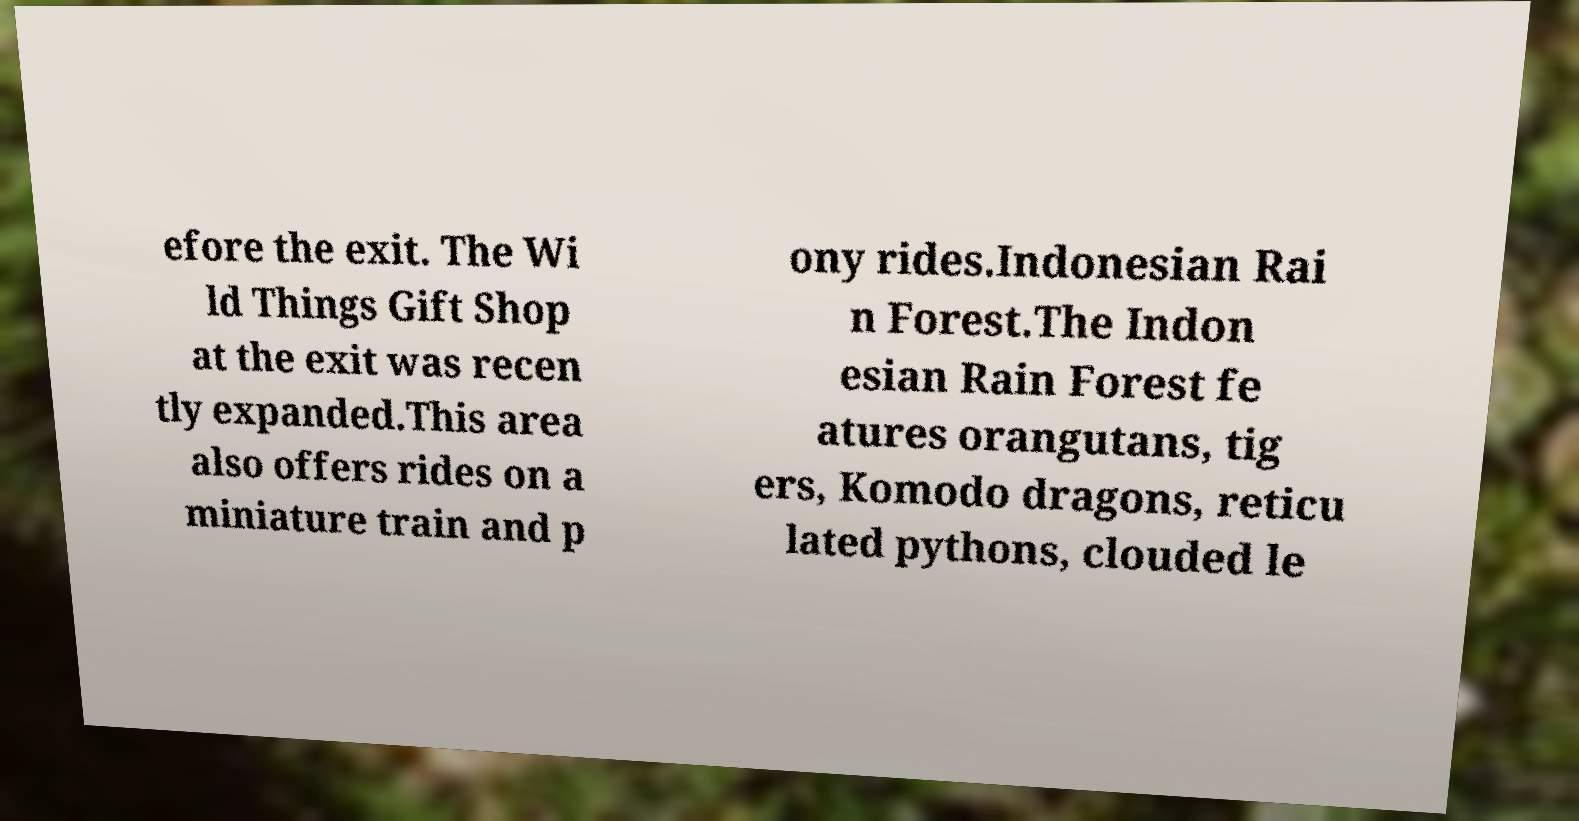I need the written content from this picture converted into text. Can you do that? efore the exit. The Wi ld Things Gift Shop at the exit was recen tly expanded.This area also offers rides on a miniature train and p ony rides.Indonesian Rai n Forest.The Indon esian Rain Forest fe atures orangutans, tig ers, Komodo dragons, reticu lated pythons, clouded le 